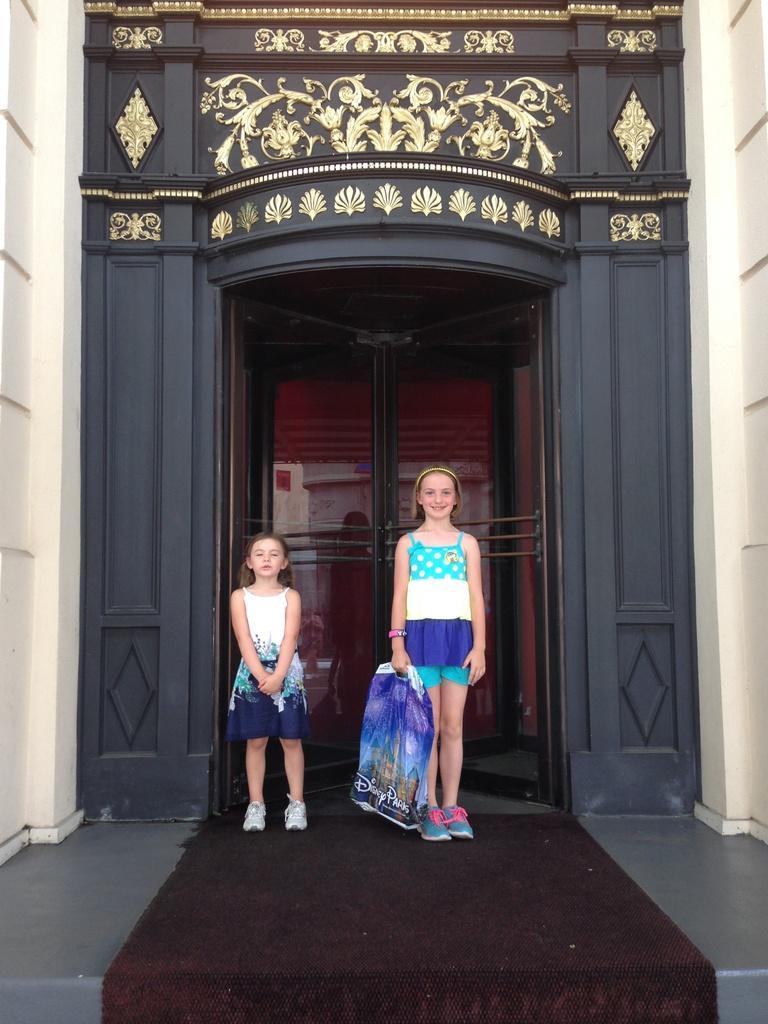How many girls are in the image? There are two small girls in the image. What are the girls doing in the image? The girls are standing and looking at the camera. What can be seen in the background of the image? There is a brown and golden color door in the background. What is the color of the wall on the side? There is a white wall on the side. What type of brass instrument is the girls playing in the image? There is no brass instrument present in the image; the girls are simply standing and looking at the camera. 